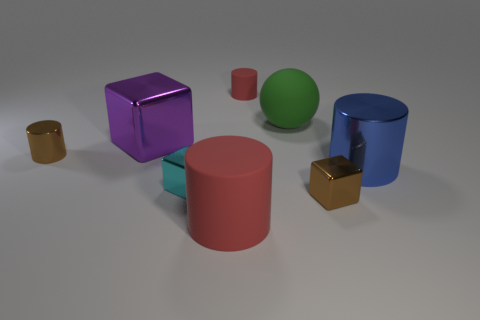Describe the different colors visible in this image. In the image, we see a range of colors: a gold hue on the smallest cylinder and the small cube, a rich purple on the large cube, pink on the medium-sized cylinder, a bold blue on the largest cylinder, and a vibrant green on the sphere. 